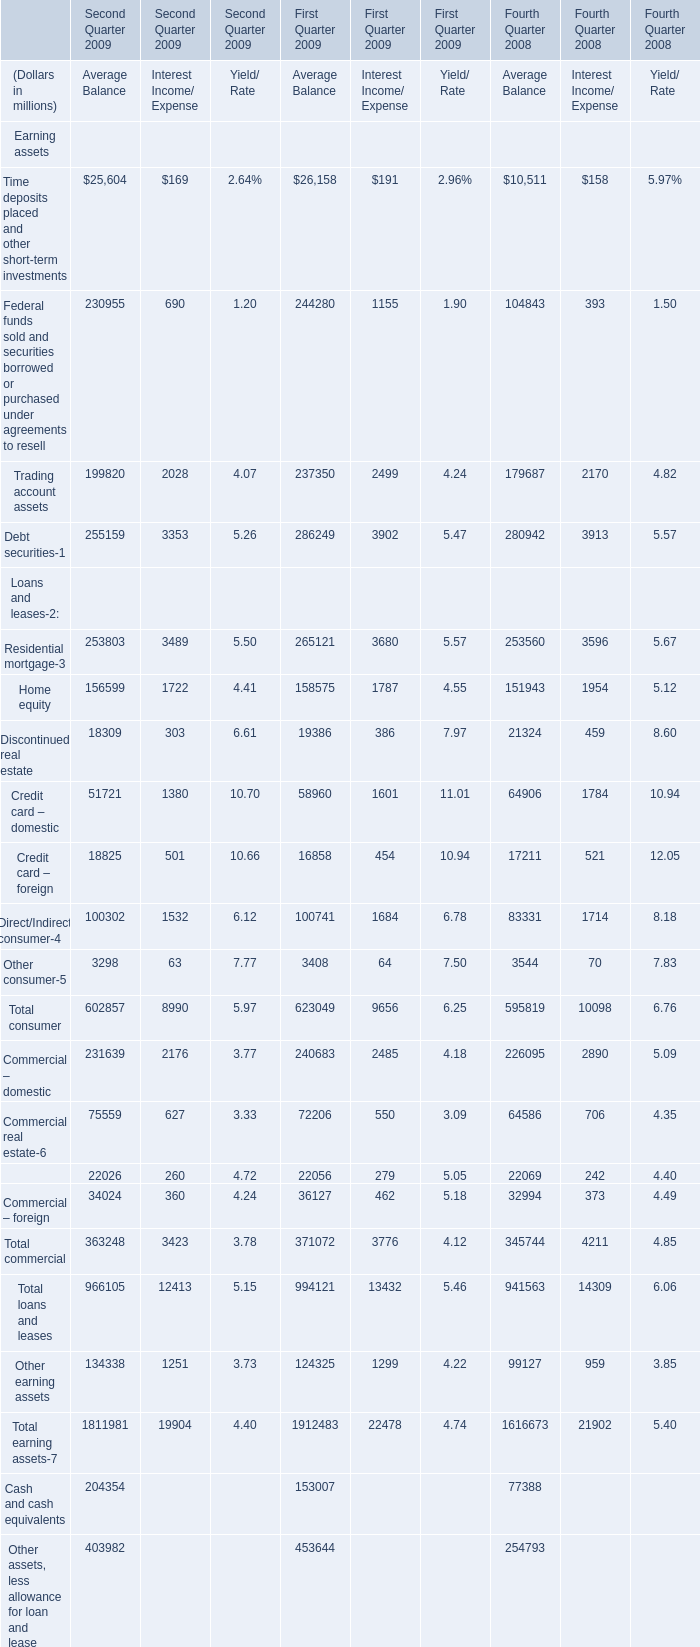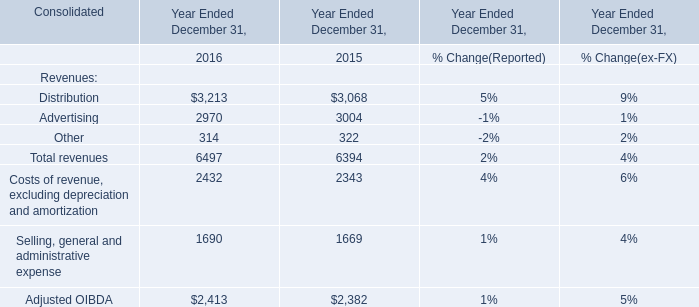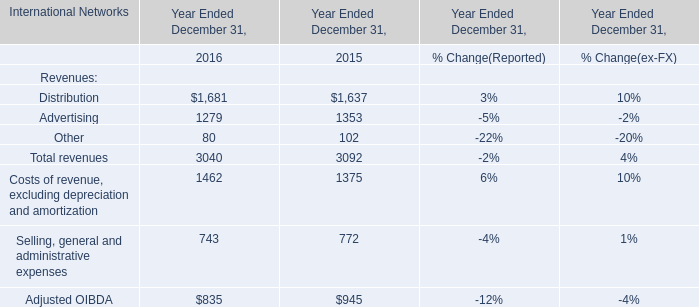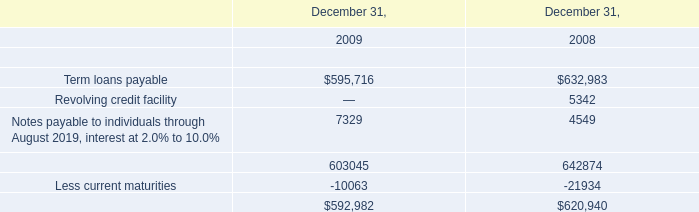What's the sum of Residential mortgage of First Quarter 2009 Average Balance, and Term loans payable of December 31, 2009 ? 
Computations: (265121.0 + 595716.0)
Answer: 860837.0. 